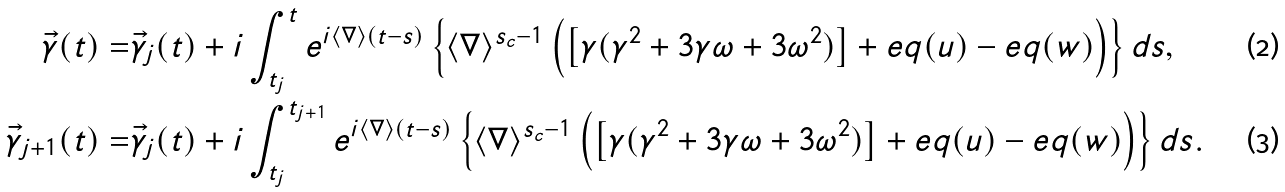<formula> <loc_0><loc_0><loc_500><loc_500>\vec { \gamma } ( t ) = & \vec { \gamma } _ { j } ( t ) + i \int _ { t _ { j } } ^ { t } e ^ { i \langle \nabla \rangle ( t - s ) } \left \{ \langle \nabla \rangle ^ { s _ { c } - 1 } \left ( \left [ \gamma ( \gamma ^ { 2 } + 3 \gamma \omega + 3 \omega ^ { 2 } ) \right ] + e q ( u ) - e q ( w ) \right ) \right \} d s , \\ \vec { \gamma } _ { j + 1 } ( t ) = & \vec { \gamma } _ { j } ( t ) + i \int _ { t _ { j } } ^ { t _ { j + 1 } } e ^ { i \langle \nabla \rangle ( t - s ) } \left \{ \langle \nabla \rangle ^ { s _ { c } - 1 } \left ( \left [ \gamma ( \gamma ^ { 2 } + 3 \gamma \omega + 3 \omega ^ { 2 } ) \right ] + e q ( u ) - e q ( w ) \right ) \right \} d s .</formula> 